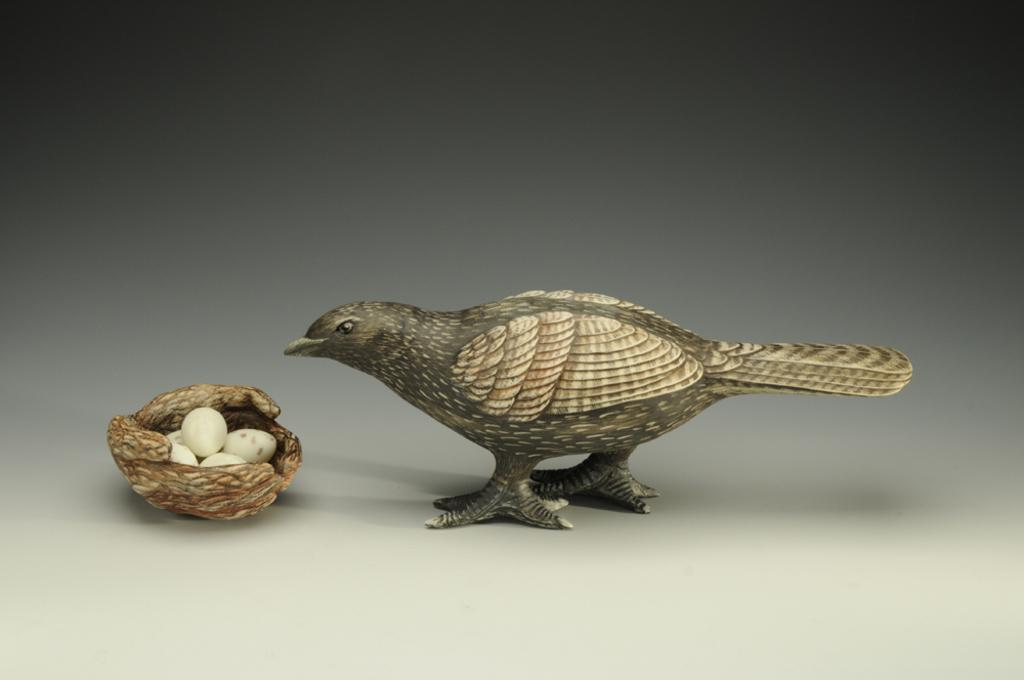What type of toy is present in the image? There is a toy bird in the image. What is located near the toy bird? There is a nest with eggs in the image. What type of space-related object can be seen in the image? There is no space-related object present in the image. What finger is holding the toy bird in the image? There is no hand or finger holding the toy bird in the image; it is likely placed on a surface or in the nest. 